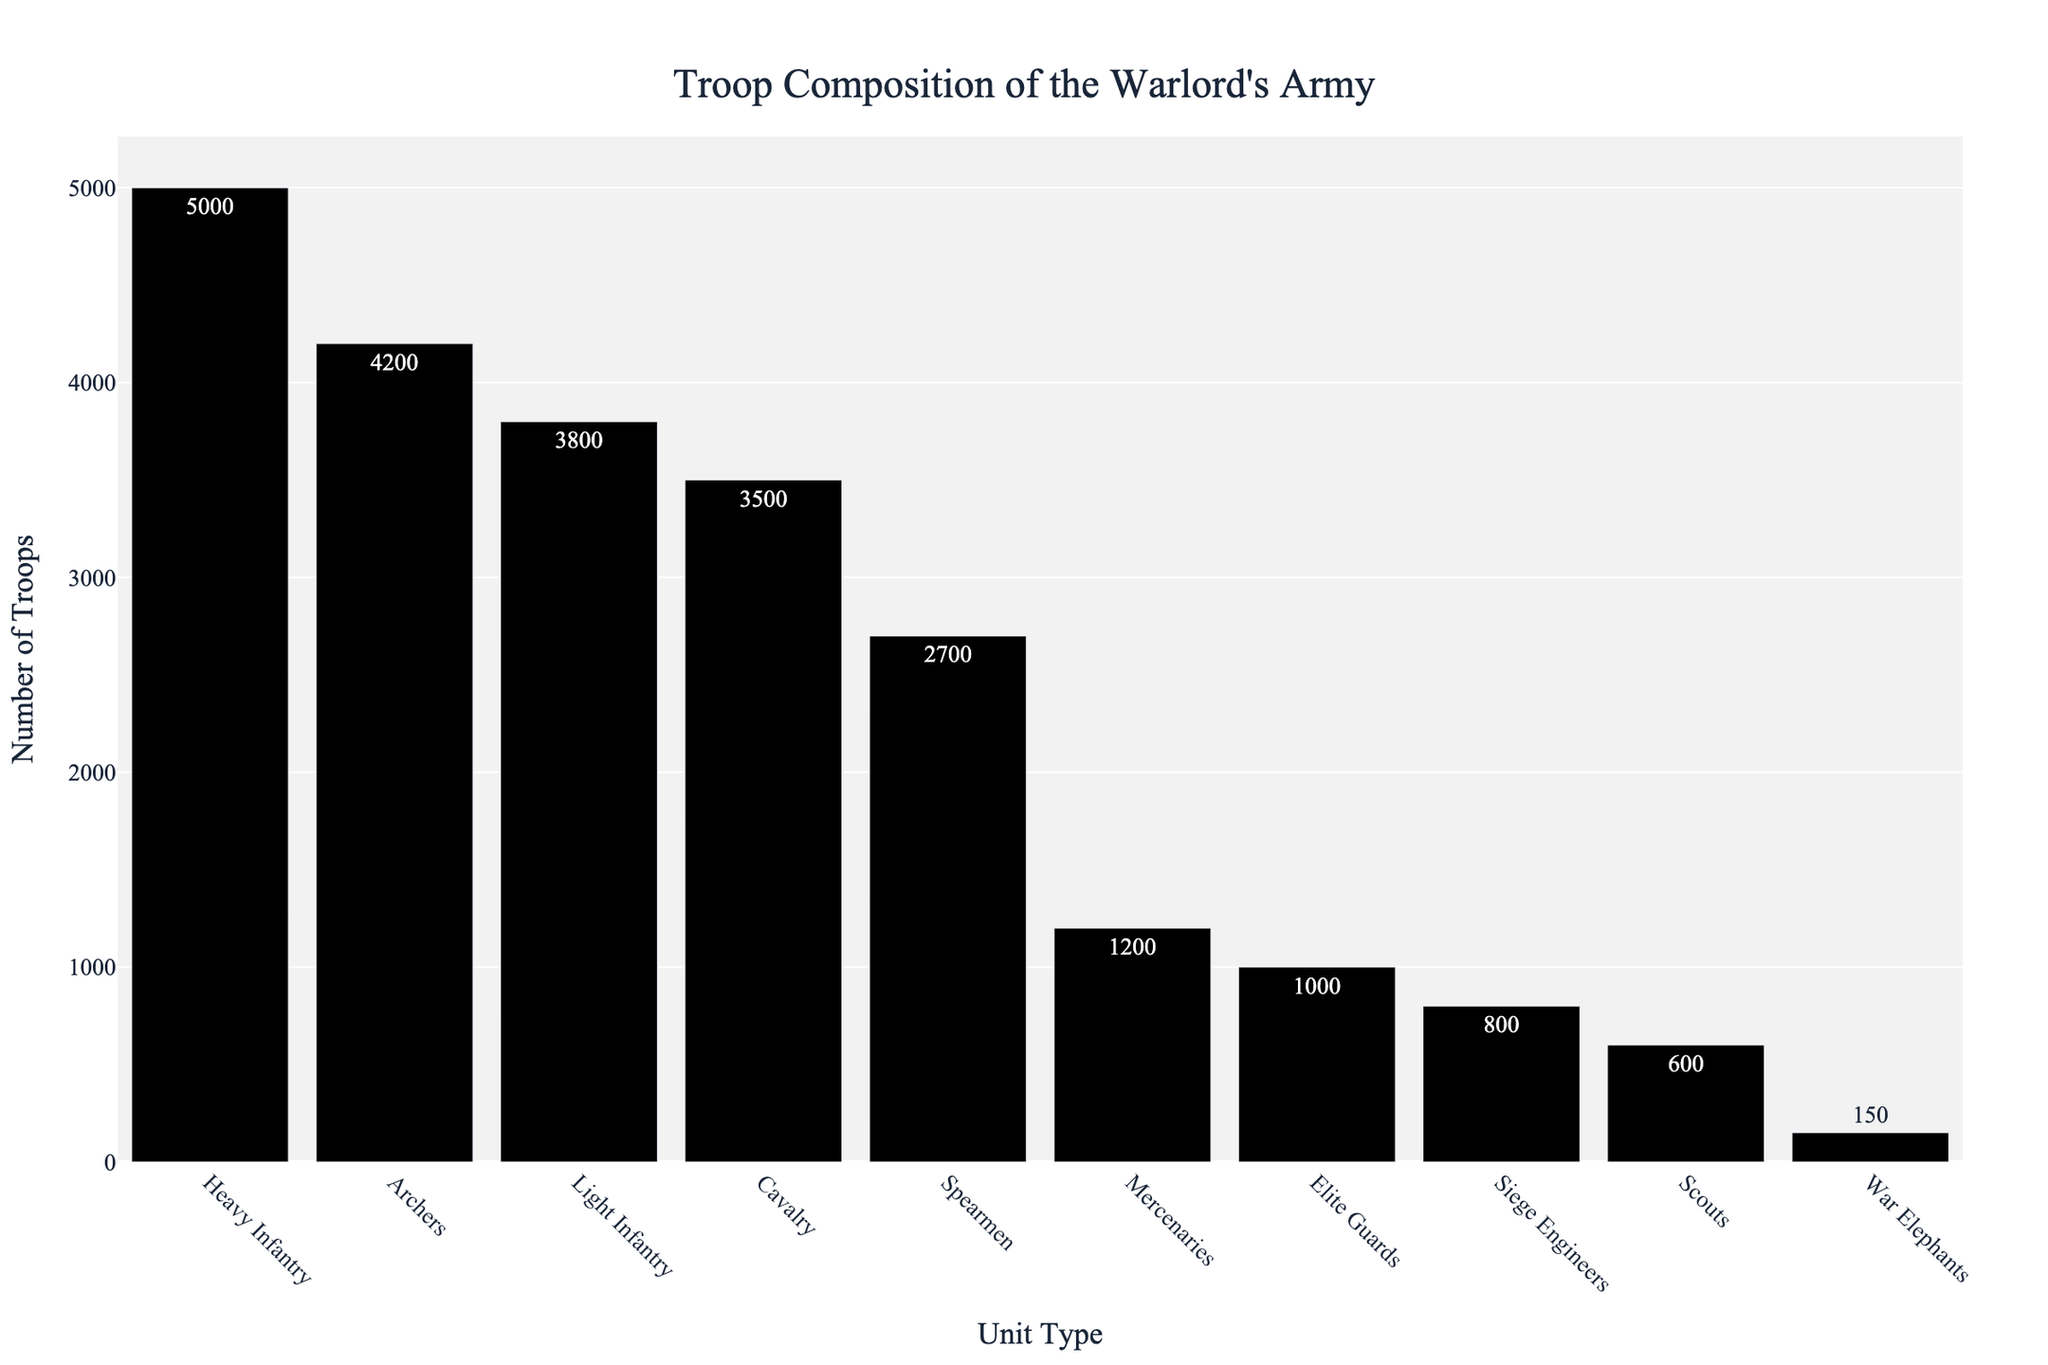What is the most numerous unit type in the warlord's army? By observing the bar chart, identify the tallest bar, which represents the unit type with the highest number. Based on the given data, the tallest bar corresponds to Heavy Infantry.
Answer: Heavy Infantry Which unit type has the least number of troops? Look for the shortest bar in the bar chart, which represents the unit type with the lowest number of troops. According to the data, the shortest bar corresponds to War Elephants.
Answer: War Elephants How many more Heavy Infantry are there compared to Light Infantry? First, find the number of Heavy Infantry, which is 5000. Then, find the number of Light Infantry, which is 3800. Subtract the number of Light Infantry from the number of Heavy Infantry: 5000 - 3800 = 1200.
Answer: 1200 What is the combined number of Archers, Spearmen, and Scouts in the army? Identify and sum the number of troops for Archers (4200), Spearmen (2700), and Scouts (600). The total is 4200 + 2700 + 600 = 7500.
Answer: 7500 Which unit type has numbers closest to the mean troop count of the army? Calculate the mean troop count by summing all the unit counts and dividing them by the number of units: (5000 + 3500 + 4200 + 800 + 3800 + 2700 + 1000 + 600 + 150 + 1200) / 10 = 23150 / 10 = 2315. The unit count closest to 2315 is that of the Mercenaries (1200).
Answer: Mercenaries By how much do the Archers outnumber the Spearmen in the warlord's army? Identify the number of Archers (4200) and the number of Spearmen (2700). Subtract the number of Spearmen from the number of Archers: 4200 - 2700 = 1500.
Answer: 1500 What is the total number of troops in the warlord's army? Sum the number of troops for all units: 5000 + 3500 + 4200 + 800 + 3800 + 2700 + 1000 + 600 + 150 + 1200 = 23150.
Answer: 23150 What is the difference in the number of troops between the unit with the highest count and the unit with the lowest count? Subtract the number of the unit with the lowest count (War Elephants, 150) from the unit with the highest count (Heavy Infantry, 5000): 5000 - 150 = 4850.
Answer: 4850 